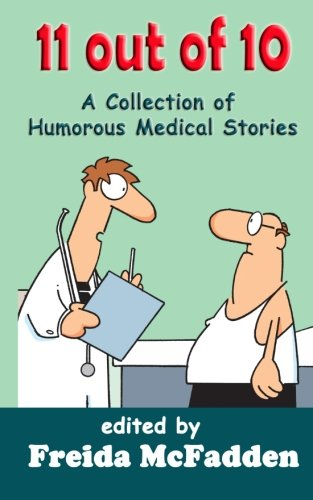What is the genre of this book? Despite the erroneous initial categorization, the book falls within the humor and medical literature genres, focusing on light-hearted, humorous stories set in medical contexts. 